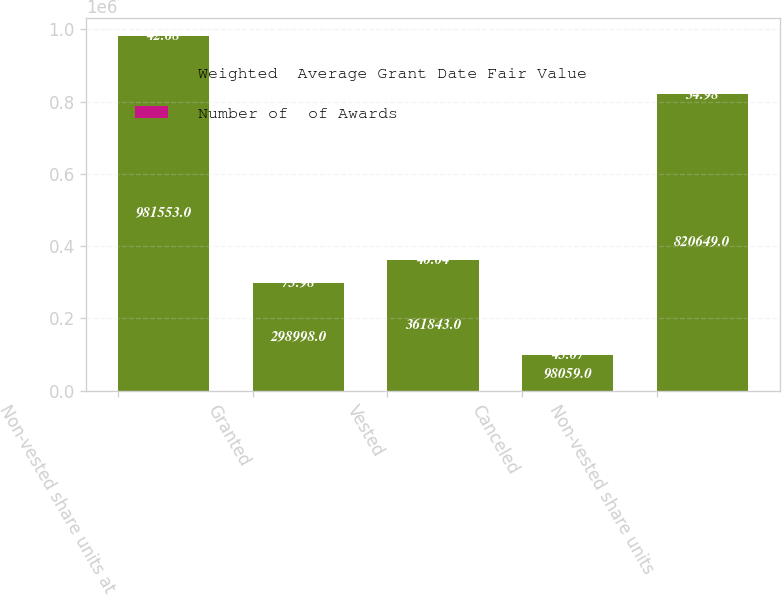Convert chart to OTSL. <chart><loc_0><loc_0><loc_500><loc_500><stacked_bar_chart><ecel><fcel>Non-vested share units at<fcel>Granted<fcel>Vested<fcel>Canceled<fcel>Non-vested share units<nl><fcel>Weighted  Average Grant Date Fair Value<fcel>981553<fcel>298998<fcel>361843<fcel>98059<fcel>820649<nl><fcel>Number of  of Awards<fcel>42.68<fcel>73.98<fcel>40.04<fcel>45.07<fcel>54.98<nl></chart> 